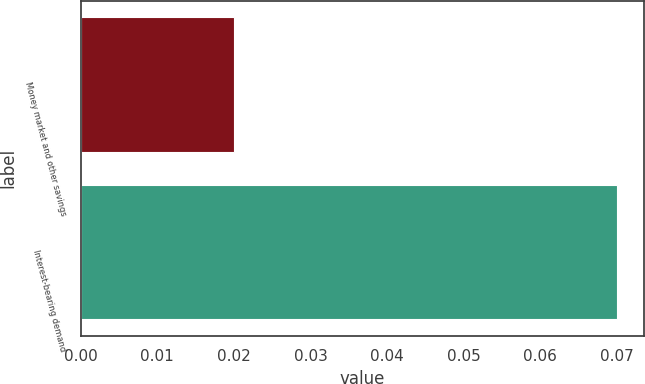<chart> <loc_0><loc_0><loc_500><loc_500><bar_chart><fcel>Money market and other savings<fcel>Interest-bearing demand<nl><fcel>0.02<fcel>0.07<nl></chart> 